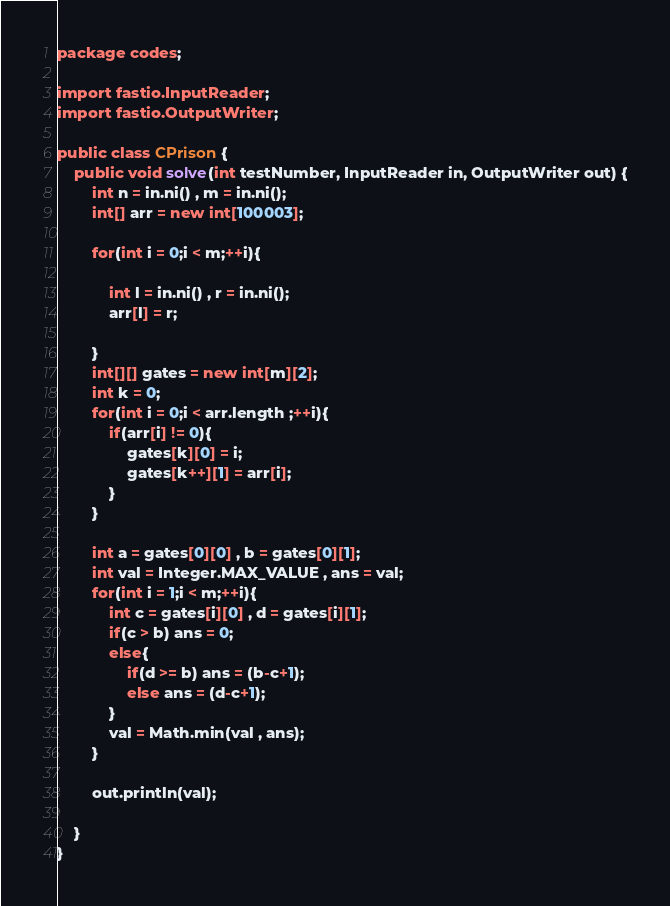<code> <loc_0><loc_0><loc_500><loc_500><_Java_>package codes;

import fastio.InputReader;
import fastio.OutputWriter;

public class CPrison {
    public void solve(int testNumber, InputReader in, OutputWriter out) {
        int n = in.ni() , m = in.ni();
        int[] arr = new int[100003];

        for(int i = 0;i < m;++i){

            int l = in.ni() , r = in.ni();
            arr[l] = r;

        }
        int[][] gates = new int[m][2];
        int k = 0;
        for(int i = 0;i < arr.length ;++i){
            if(arr[i] != 0){
                gates[k][0] = i;
                gates[k++][1] = arr[i];
            }
        }

        int a = gates[0][0] , b = gates[0][1];
        int val = Integer.MAX_VALUE , ans = val;
        for(int i = 1;i < m;++i){
            int c = gates[i][0] , d = gates[i][1];
            if(c > b) ans = 0;
            else{
                if(d >= b) ans = (b-c+1);
                else ans = (d-c+1);
            }
            val = Math.min(val , ans);
        }

        out.println(val);

    }
}
</code> 